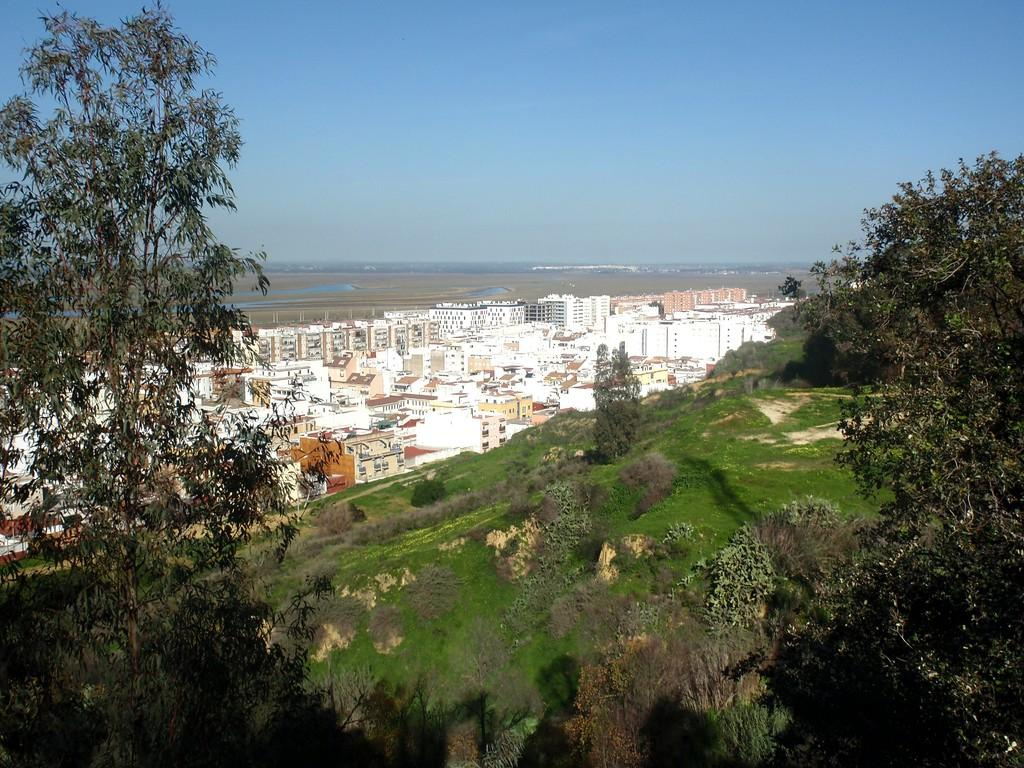What type of vegetation is present in the image? There are trees in the image. What type of ground cover is present in the image? There is grass in the image. What type of man-made structures are present in the image? There are buildings in the image. What is visible in the background of the image? The sky is visible in the background of the image. What type of eggnog can be seen in the image? There is no eggnog present in the image. How many holes are visible in the trees in the image? There are no holes visible in the trees in the image. 